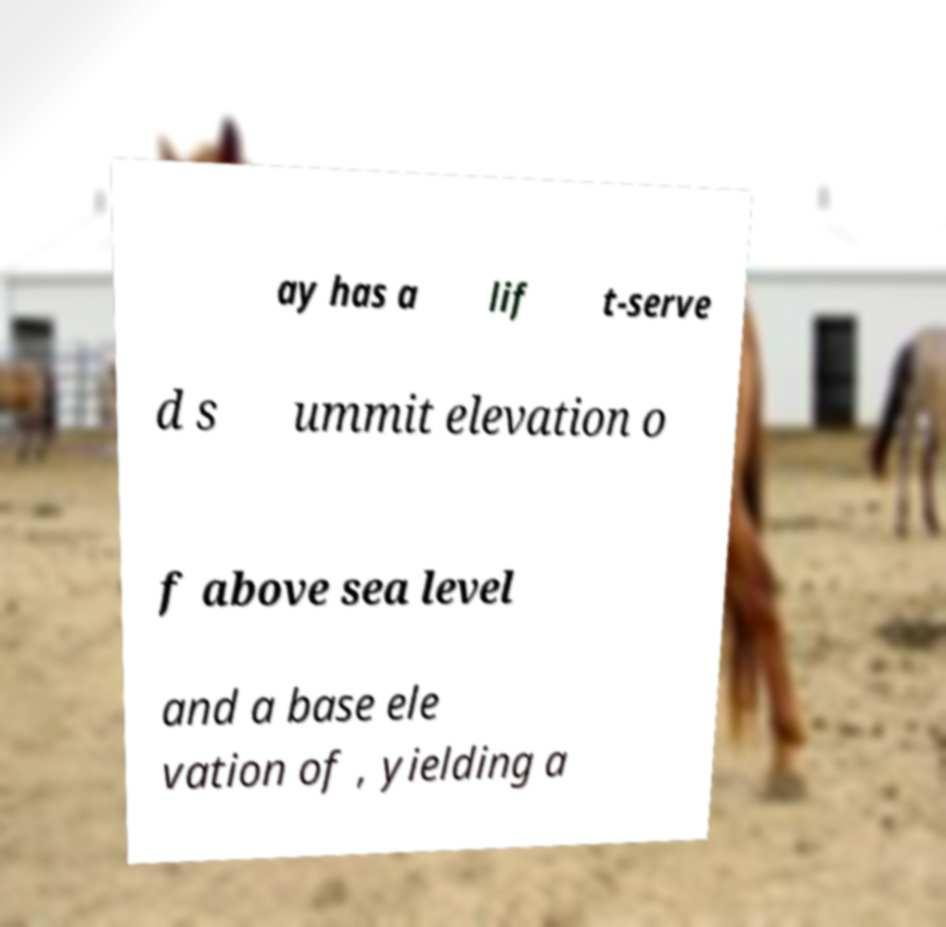Please identify and transcribe the text found in this image. ay has a lif t-serve d s ummit elevation o f above sea level and a base ele vation of , yielding a 